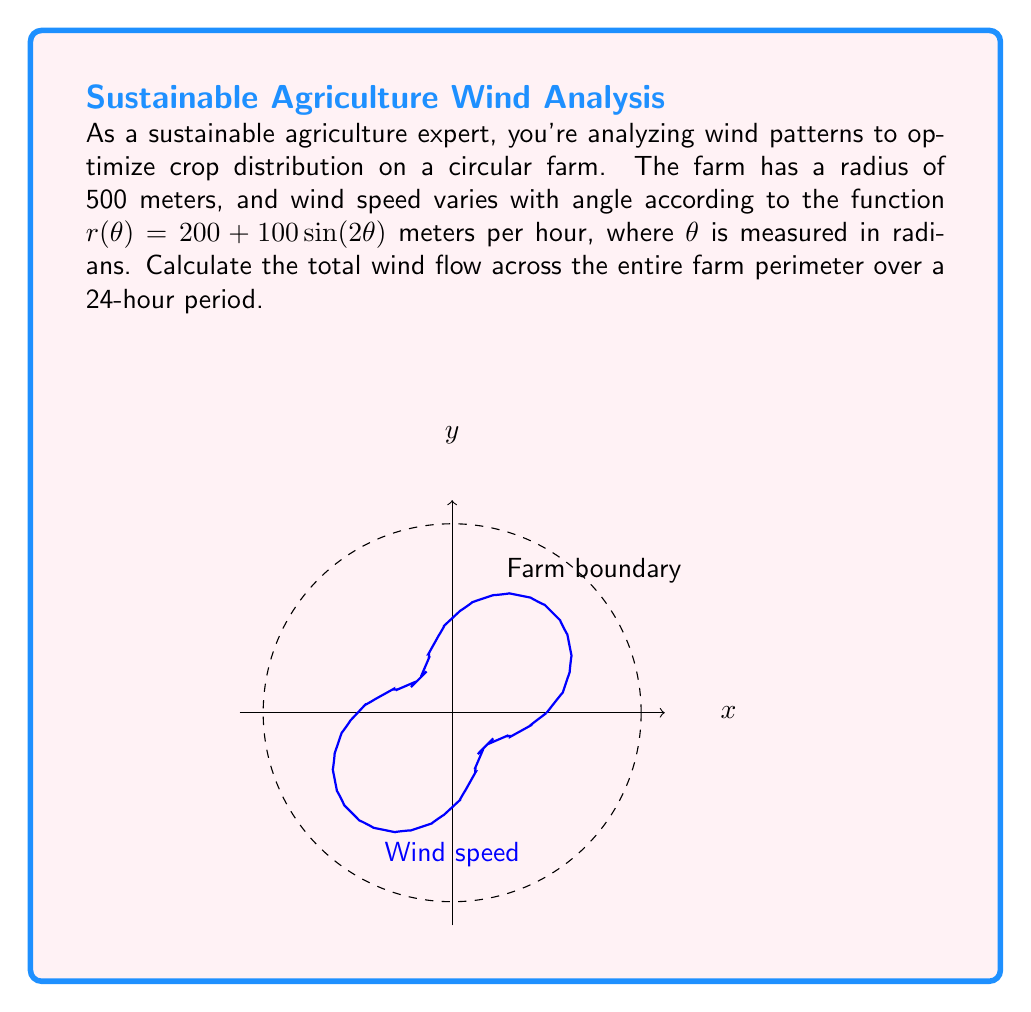Can you solve this math problem? Let's approach this step-by-step:

1) The wind flow across a small segment of the farm's perimeter is given by the product of the wind speed and the length of the segment. In polar coordinates, this is represented by $r(\theta) \cdot r d\theta$.

2) To find the total wind flow, we need to integrate this over the entire circumference:

   $\text{Total Flow} = \int_0^{2\pi} r(\theta) \cdot r d\theta$

3) We're given $r = 500$ (farm radius) and $r(\theta) = 200 + 100\sin(2\theta)$ (wind speed). Substituting:

   $\text{Total Flow} = \int_0^{2\pi} (200 + 100\sin(2\theta)) \cdot 500 d\theta$

4) Simplify:
   
   $\text{Total Flow} = 500 \int_0^{2\pi} (200 + 100\sin(2\theta)) d\theta$

5) Integrate:
   
   $\text{Total Flow} = 500 [200\theta - 50\cos(2\theta)]_0^{2\pi}$

6) Evaluate:
   
   $\text{Total Flow} = 500 [(200 \cdot 2\pi - 50\cos(4\pi)) - (0 - 50\cos(0))]$
   
   $\text{Total Flow} = 500 [400\pi - 50 + 50]$
   
   $\text{Total Flow} = 500 \cdot 400\pi = 200,000\pi$ meter²/hour

7) For a 24-hour period:

   $\text{Total Flow (24 hours)} = 200,000\pi \cdot 24 = 4,800,000\pi$ meter²
Answer: $4,800,000\pi$ m² 